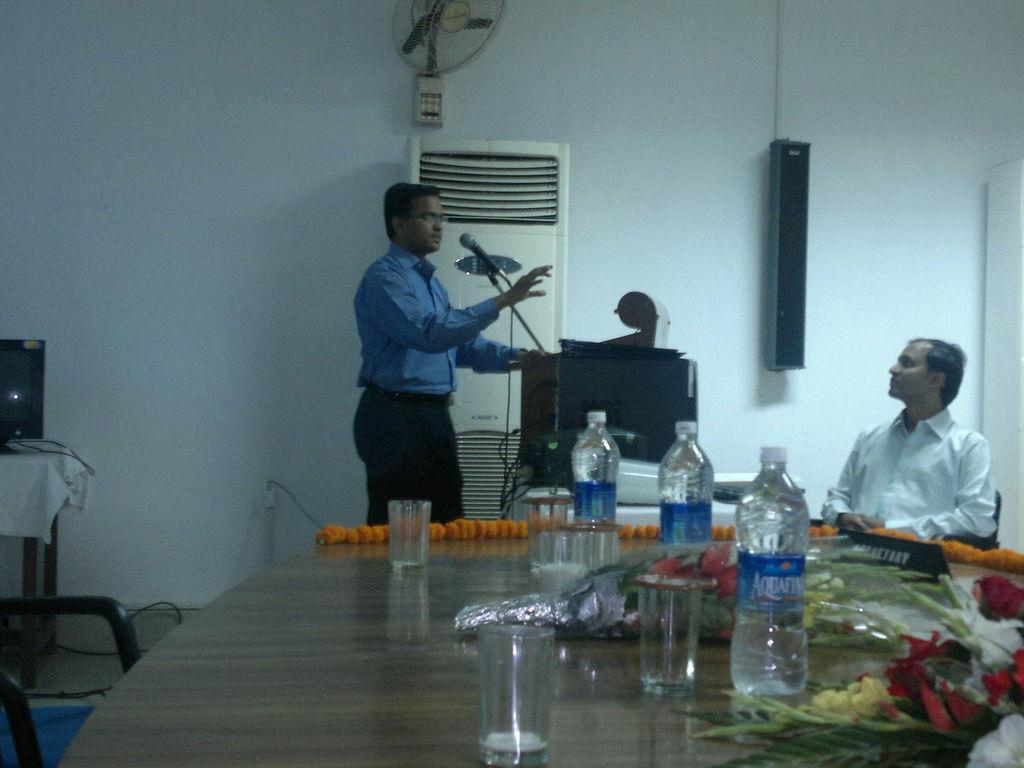In one or two sentences, can you explain what this image depicts? In this picture we can see a man standing in front of a podium, we can see a microphone here, on the right side there is a man sitting on a chair, we can see a table here, there are some bottles, glasses, flowers on the table, in the background there is a wall, we can see speaker here, there is a man here, on the left side there is a television. 